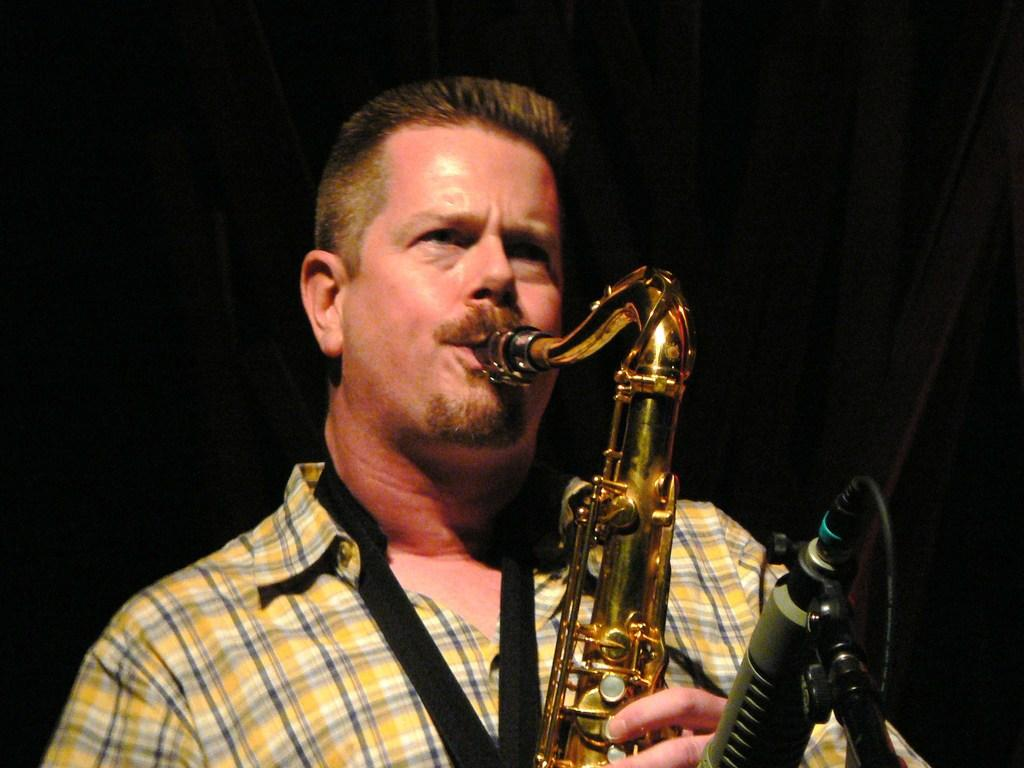What is the main subject of the image? There is a person in the image. What is the person doing in the image? The person is playing a musical instrument. Can you describe the background of the image? The background of the image is dark. What type of toy can be seen on the coast in the image? There is no coast or toy present in the image; it features a person playing a musical instrument with a dark background. 